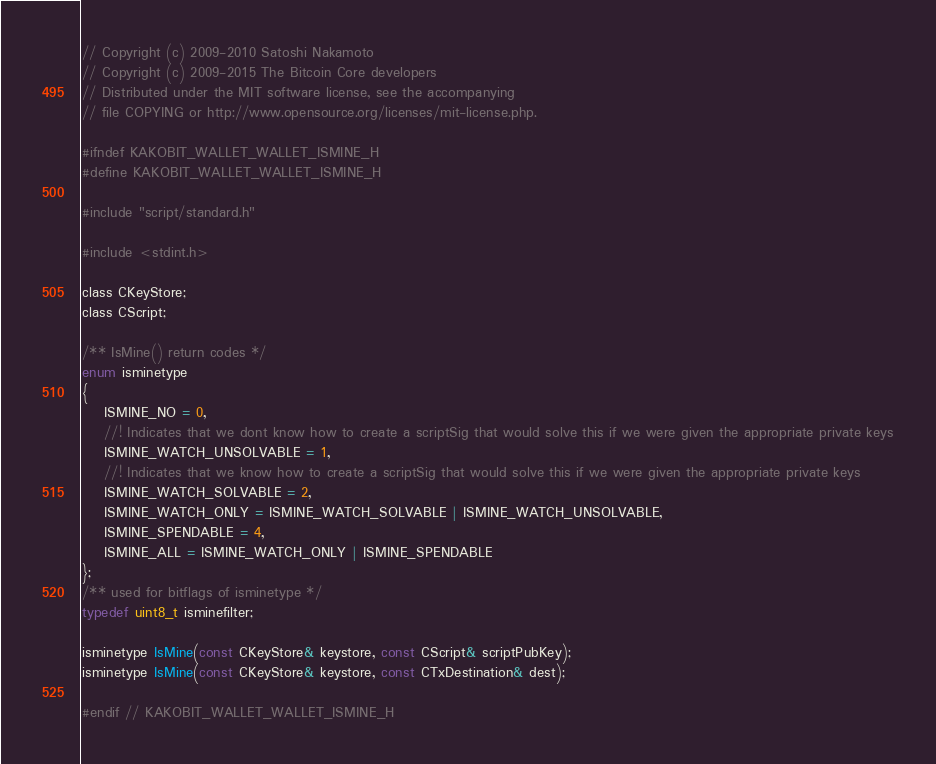<code> <loc_0><loc_0><loc_500><loc_500><_C_>// Copyright (c) 2009-2010 Satoshi Nakamoto
// Copyright (c) 2009-2015 The Bitcoin Core developers
// Distributed under the MIT software license, see the accompanying
// file COPYING or http://www.opensource.org/licenses/mit-license.php.

#ifndef KAKOBIT_WALLET_WALLET_ISMINE_H
#define KAKOBIT_WALLET_WALLET_ISMINE_H

#include "script/standard.h"

#include <stdint.h>

class CKeyStore;
class CScript;

/** IsMine() return codes */
enum isminetype
{
    ISMINE_NO = 0,
    //! Indicates that we dont know how to create a scriptSig that would solve this if we were given the appropriate private keys
    ISMINE_WATCH_UNSOLVABLE = 1,
    //! Indicates that we know how to create a scriptSig that would solve this if we were given the appropriate private keys
    ISMINE_WATCH_SOLVABLE = 2,
    ISMINE_WATCH_ONLY = ISMINE_WATCH_SOLVABLE | ISMINE_WATCH_UNSOLVABLE,
    ISMINE_SPENDABLE = 4,
    ISMINE_ALL = ISMINE_WATCH_ONLY | ISMINE_SPENDABLE
};
/** used for bitflags of isminetype */
typedef uint8_t isminefilter;

isminetype IsMine(const CKeyStore& keystore, const CScript& scriptPubKey);
isminetype IsMine(const CKeyStore& keystore, const CTxDestination& dest);

#endif // KAKOBIT_WALLET_WALLET_ISMINE_H
</code> 